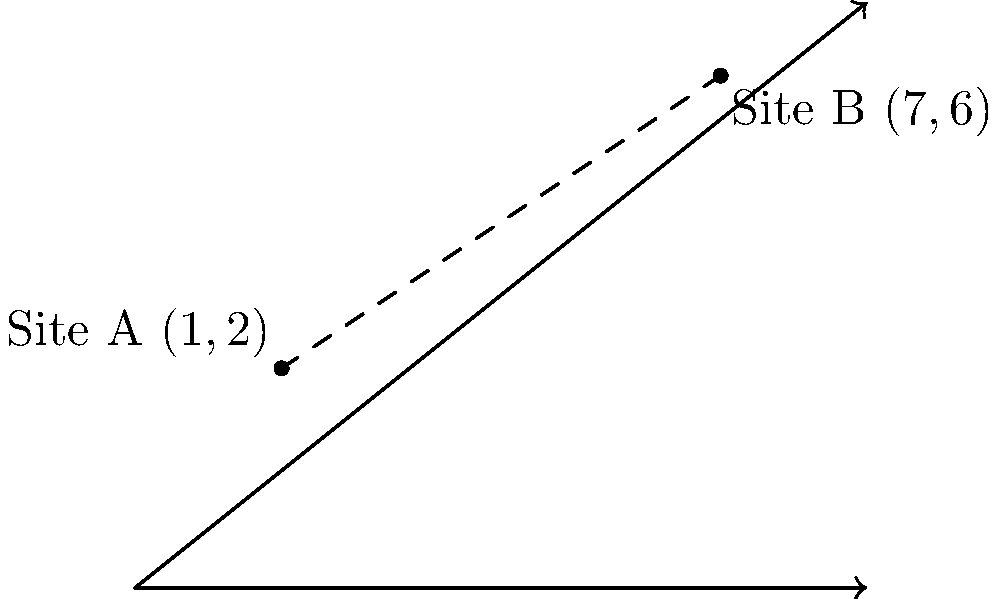In your anthropological fieldwork, you are studying two ancient cultural sites represented on a coordinate plane. Site A is located at (1,2) and Site B is at (7,6). Calculate the distance between these two sites using the distance formula. Round your answer to two decimal places. To find the distance between two points on a coordinate plane, we use the distance formula:

$$d = \sqrt{(x_2 - x_1)^2 + (y_2 - y_1)^2}$$

Where $(x_1, y_1)$ represents the coordinates of the first point and $(x_2, y_2)$ represents the coordinates of the second point.

For our problem:
Site A: $(x_1, y_1) = (1, 2)$
Site B: $(x_2, y_2) = (7, 6)$

Let's plug these values into the formula:

$$d = \sqrt{(7 - 1)^2 + (6 - 2)^2}$$

Simplify:
$$d = \sqrt{6^2 + 4^2}$$

Calculate the squares:
$$d = \sqrt{36 + 16}$$

Add under the square root:
$$d = \sqrt{52}$$

Calculate the square root:
$$d \approx 7.21110255$$

Rounding to two decimal places:
$$d \approx 7.21$$

Therefore, the distance between Site A and Site B is approximately 7.21 units.
Answer: 7.21 units 